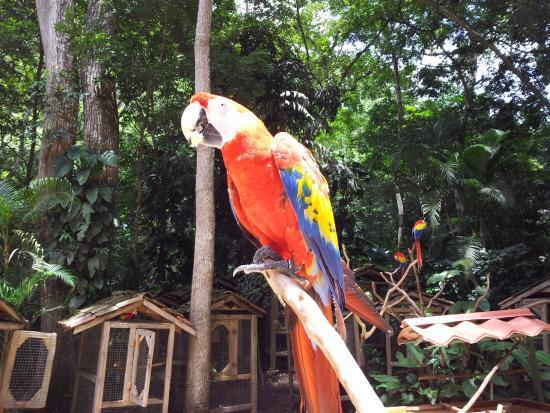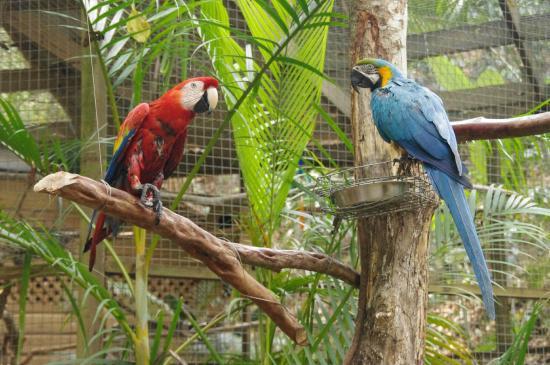The first image is the image on the left, the second image is the image on the right. Considering the images on both sides, is "There is one predominately red bird perched in the image on the left." valid? Answer yes or no. Yes. The first image is the image on the left, the second image is the image on the right. Evaluate the accuracy of this statement regarding the images: "No image contains more than two parrot-type birds, and each image contains exactly one red-headed bird.". Is it true? Answer yes or no. Yes. 